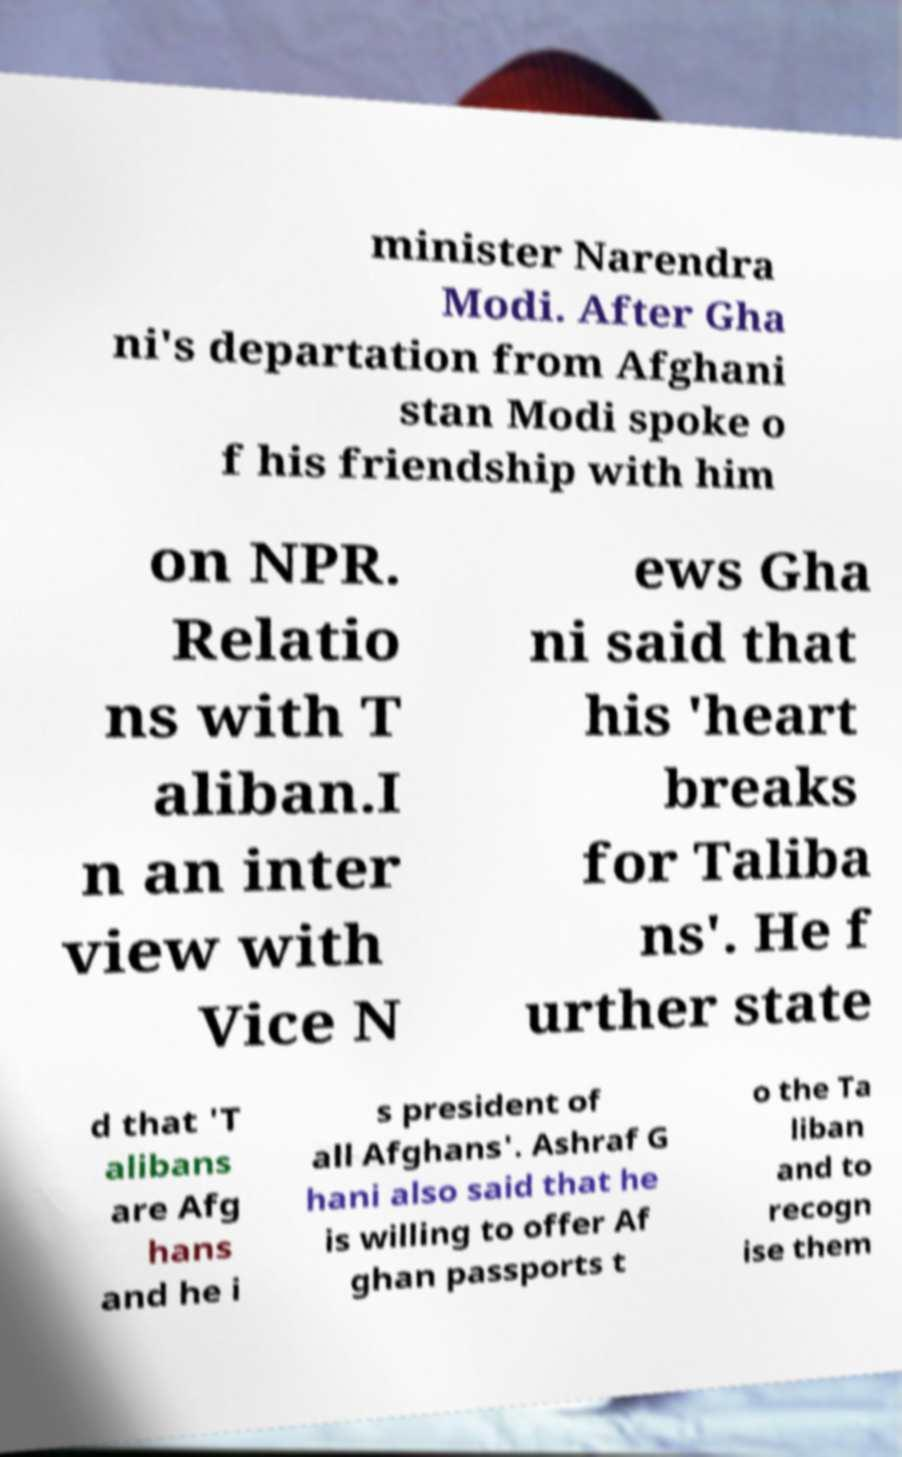Could you assist in decoding the text presented in this image and type it out clearly? minister Narendra Modi. After Gha ni's departation from Afghani stan Modi spoke o f his friendship with him on NPR. Relatio ns with T aliban.I n an inter view with Vice N ews Gha ni said that his 'heart breaks for Taliba ns'. He f urther state d that 'T alibans are Afg hans and he i s president of all Afghans'. Ashraf G hani also said that he is willing to offer Af ghan passports t o the Ta liban and to recogn ise them 